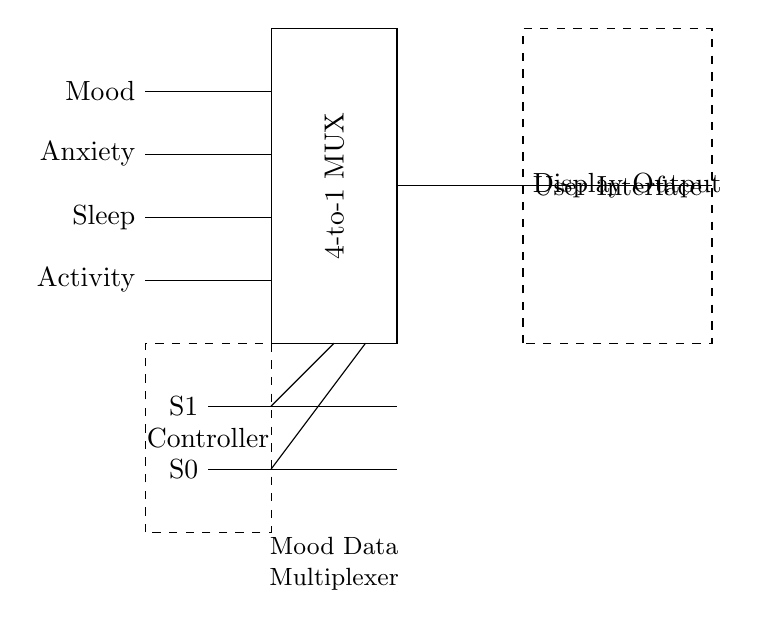What type of multiplexer is shown? The circuit diagram shows a 4-to-1 multiplexer. A multiplexer, or MUX, is a device that selects one of several input signals and forwards the selected input into a single line. The diagram explicitly labels the multiplexer as "4-to-1", indicating it has four input lines and one output line.
Answer: 4-to-1 What inputs are being multiplexed? The inputs labeled in the circuit diagram are Mood, Anxiety, Sleep, and Activity. Each label represents a different type of mood data that the multiplexer selects from. By examining the input lines drawn into the multiplexer, we can identify these four specific inputs.
Answer: Mood, Anxiety, Sleep, Activity What does the 'S1' and 'S0' represent? 'S1' and 'S0' represent the select lines for the multiplexer. These lines determine which input is connected to the output. In this case, S1 and S0 are two control signals used to select one of the four inputs, indicating it's a binary selection with two select lines.
Answer: Select lines What is connected to the output of the multiplexer? The output of the multiplexer is connected to the "Display Output". This connection indicates that the selected input from the multiplexer is sent to a display interface, which presumably shows the selected mood data to the user.
Answer: Display Output How many total inputs does this multiplexer have? The multiplexer has a total of four inputs, as indicated by the input lines for Mood, Anxiety, Sleep, and Activity. The diagram clearly shows four separate input lines merging into the multiplexer itself, specifying the number of inputs directly.
Answer: Four What is the role of the dashed rectangle labeled "Controller"? The dashed rectangle labeled "Controller" is where control logic resides to select which input to send to the output based on the user interface selection. It represents the part of the circuit that manages select lines S1 and S0, determining how the multiplexer will operate.
Answer: Controls selection 